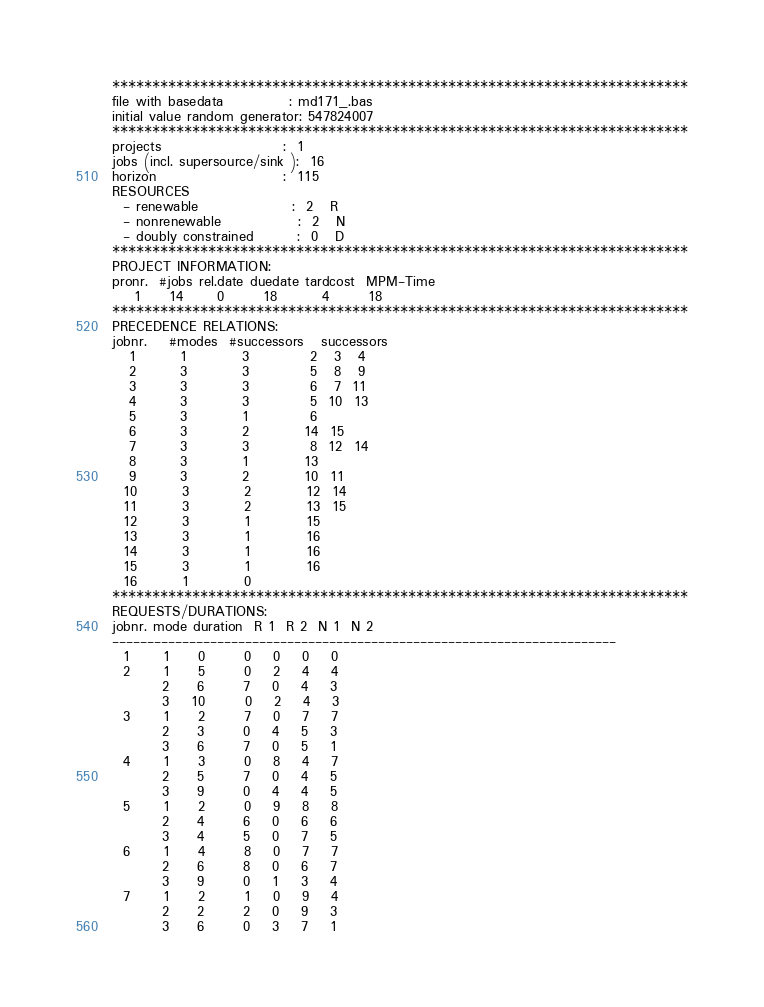Convert code to text. <code><loc_0><loc_0><loc_500><loc_500><_ObjectiveC_>************************************************************************
file with basedata            : md171_.bas
initial value random generator: 547824007
************************************************************************
projects                      :  1
jobs (incl. supersource/sink ):  16
horizon                       :  115
RESOURCES
  - renewable                 :  2   R
  - nonrenewable              :  2   N
  - doubly constrained        :  0   D
************************************************************************
PROJECT INFORMATION:
pronr.  #jobs rel.date duedate tardcost  MPM-Time
    1     14      0       18        4       18
************************************************************************
PRECEDENCE RELATIONS:
jobnr.    #modes  #successors   successors
   1        1          3           2   3   4
   2        3          3           5   8   9
   3        3          3           6   7  11
   4        3          3           5  10  13
   5        3          1           6
   6        3          2          14  15
   7        3          3           8  12  14
   8        3          1          13
   9        3          2          10  11
  10        3          2          12  14
  11        3          2          13  15
  12        3          1          15
  13        3          1          16
  14        3          1          16
  15        3          1          16
  16        1          0        
************************************************************************
REQUESTS/DURATIONS:
jobnr. mode duration  R 1  R 2  N 1  N 2
------------------------------------------------------------------------
  1      1     0       0    0    0    0
  2      1     5       0    2    4    4
         2     6       7    0    4    3
         3    10       0    2    4    3
  3      1     2       7    0    7    7
         2     3       0    4    5    3
         3     6       7    0    5    1
  4      1     3       0    8    4    7
         2     5       7    0    4    5
         3     9       0    4    4    5
  5      1     2       0    9    8    8
         2     4       6    0    6    6
         3     4       5    0    7    5
  6      1     4       8    0    7    7
         2     6       8    0    6    7
         3     9       0    1    3    4
  7      1     2       1    0    9    4
         2     2       2    0    9    3
         3     6       0    3    7    1</code> 